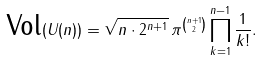<formula> <loc_0><loc_0><loc_500><loc_500>\text {Vol} ( U ( n ) ) = \sqrt { n \cdot 2 ^ { n + 1 } } \, \pi ^ { \binom { n + 1 } { 2 } } \prod _ { k = 1 } ^ { n - 1 } \frac { 1 } { k ! } .</formula> 